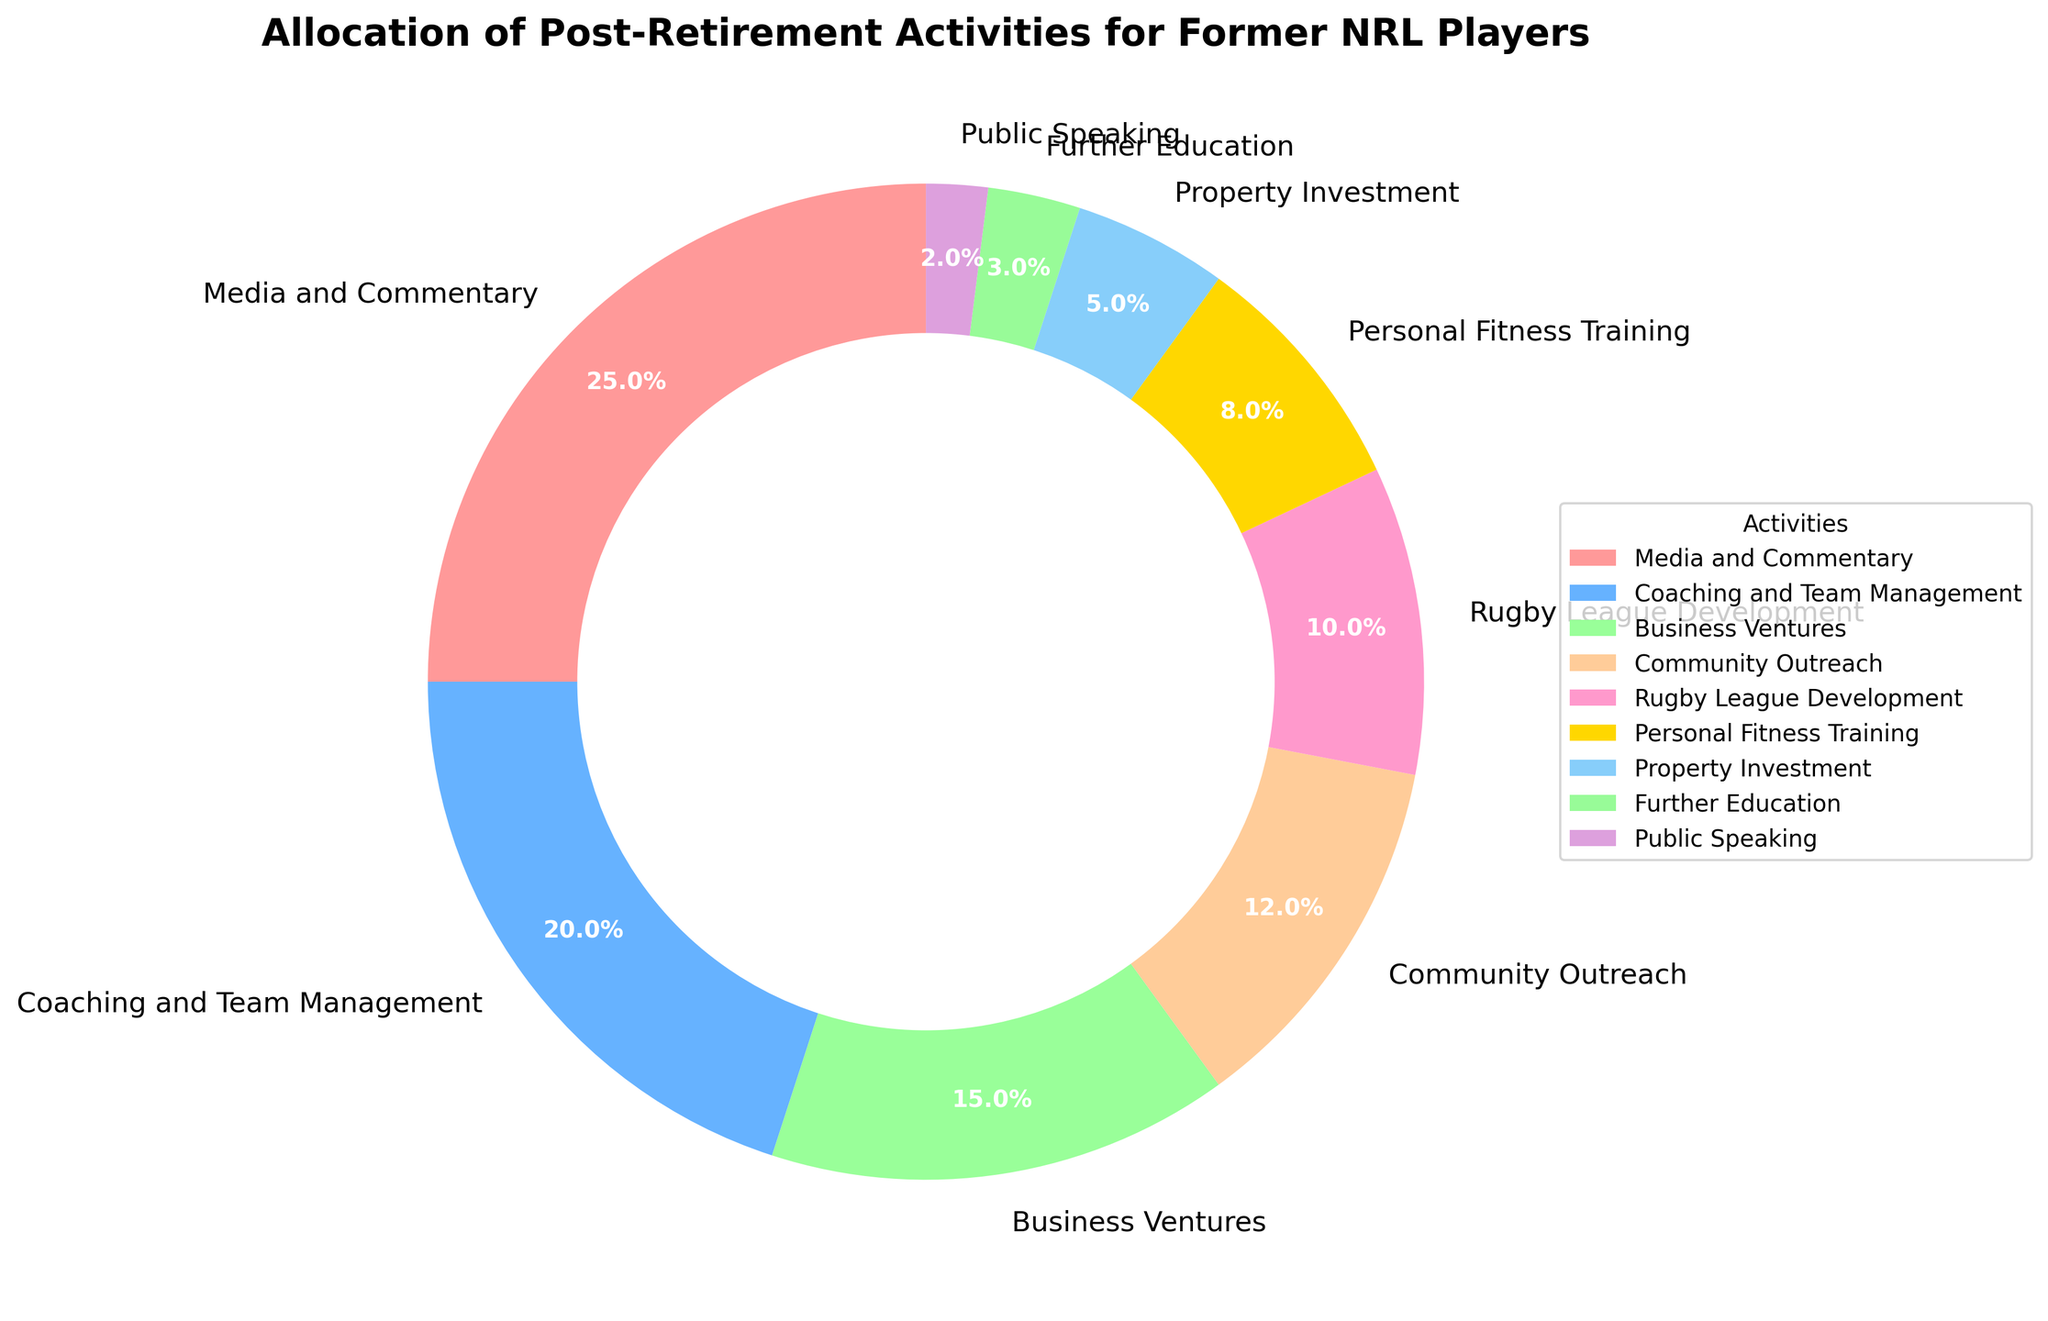Which activity do most former NRL players from Jason Nightingale's era engage in post-retirement? By looking at the pie chart, we can see that the largest segment is labeled "Media and Commentary" with a percentage of 25%. This indicates that the majority of former NRL players from Jason Nightingale's era engage in Media and Commentary activities.
Answer: Media and Commentary What is the combined percentage of former players involved in "Coaching and Team Management" and "Business Ventures"? Summing up the percentages from the pie chart for "Coaching and Team Management" (20%) and "Business Ventures" (15%), we get 20 + 15 = 35%.
Answer: 35% How does the percentage of players involved in "Personal Fitness Training" compare to those in "Property Investment"? From the pie chart, the percentage of former players involved in "Personal Fitness Training" is 8% and those in "Property Investment" is 5%. Comparing these, "Personal Fitness Training" has a higher percentage.
Answer: Personal Fitness Training is higher What is the total percentage of players engaged in "Community Outreach", "Rugby League Development", and "Further Education"? Adding the percentages for "Community Outreach" (12%), "Rugby League Development" (10%), and "Further Education" (3%), we get 12 + 10 + 3 = 25%.
Answer: 25% Which activity has the smallest allocation of post-retirement involvement? Observing the pie chart, the smallest segment is labeled "Public Speaking" with a percentage of 2%. This indicates that "Public Speaking" has the smallest allocation of post-retirement involvement.
Answer: Public Speaking Are there more players involved in "Community Outreach" or "Property Investment"? From the pie chart, the percentage of players in "Community Outreach" is 12%, whereas in "Property Investment" it's 5%. Since 12% is greater than 5%, more players are involved in "Community Outreach".
Answer: Community Outreach How does the percentage of "Business Ventures" compare to the combined percentage of "Public Speaking" and "Further Education"? The percentage of "Business Ventures" is 15%. The combined percentage of "Public Speaking" (2%) and "Further Education" (3%) is 2 + 3 = 5%. Therefore, "Business Ventures" has a higher percentage than the combined percentage of "Public Speaking" and "Further Education".
Answer: Business Ventures is higher What three activities account for 45% of the post-retirement activities? By observing the pie chart, adding the percentages for "Media and Commentary" (25%), "Personal Fitness Training" (8%), and "Community Outreach" (12%) gives us 25 + 8 + 12 = 45%.
Answer: Media and Commentary, Personal Fitness Training, Community Outreach 